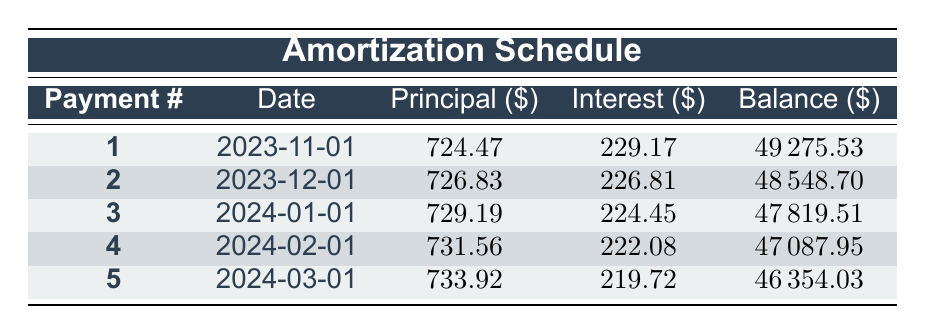What is the loan amount? The loan amount is specified in the loan details section, which states that the loan amount is 50000.
Answer: 50000 What is the total interest payment for the first month? The interest payment for the first month is listed in the table under the interest column for payment number 1, which is 229.17.
Answer: 229.17 How much principal is paid off in the second payment? The principal payment for the second payment is found in the table under the principal column for payment number 2, which is 726.83.
Answer: 726.83 What is the remaining loan balance after the fifth payment? The remaining balance after the fifth payment is recorded in the table under the balance column for payment number 5, which is 46354.03.
Answer: 46354.03 Is the interest payment for the third month greater than the interest payment for the fourth month? The interest for the third month is 224.45 and the fourth month is 222.08. Since 224.45 is greater than 222.08, the statement is true.
Answer: Yes What is the total principal paid after the first three payments? To find the total principal for the first three payments, we add the principal payments from the first, second, and third payments: 724.47 + 726.83 + 729.19 = 2180.49.
Answer: 2180.49 What is the average interest payment over the first five payments? To calculate the average, sum the interest payments for each month: 229.17 + 226.81 + 224.45 + 222.08 + 219.72 = 1122.23. Then divide by 5: 1122.23 / 5 = 224.45.
Answer: 224.45 If the monthly payment stays constant, will the remaining balance ever exceed the original loan amount during the amortization period? Since the monthly payments reduce the balance each month, and the original amount is 50000, it is impossible for the remaining balance to exceed this amount.
Answer: No Does the principal payment increase with each passing month within the first five payments? The principal payments are 724.47, 726.83, 729.19, 731.56, and 733.92, which all increase, indicating that the principal payment does indeed increase each month.
Answer: Yes 